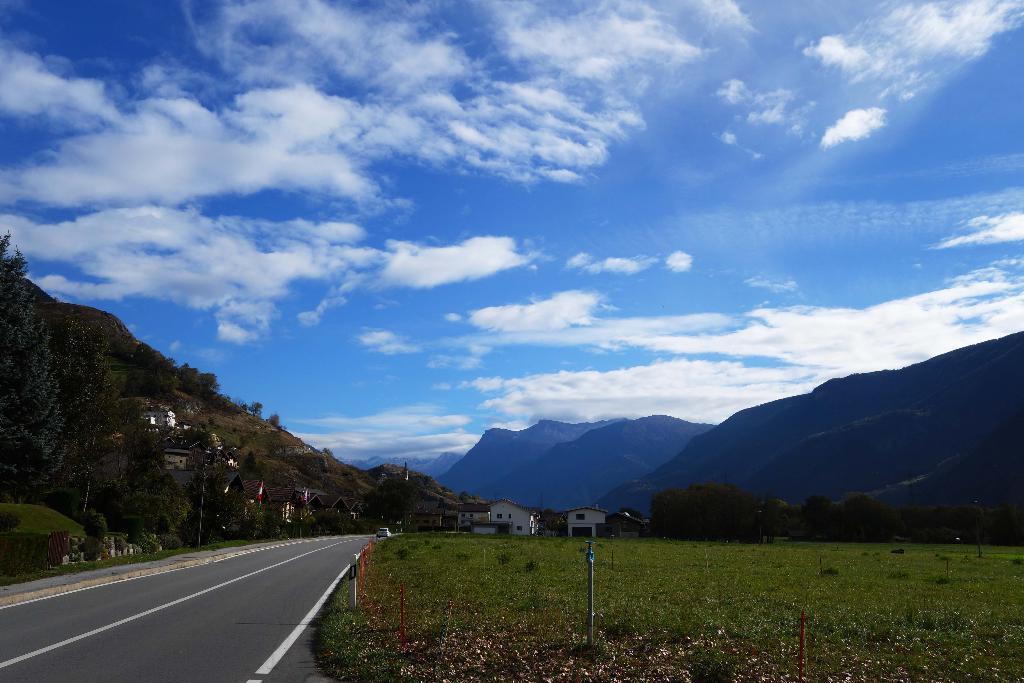In one or two sentences, can you explain what this image depicts? In this image we can see road, fencing and grassy land. We can see houses, mountains and trees in the background. The sky is in blue color with clouds. 